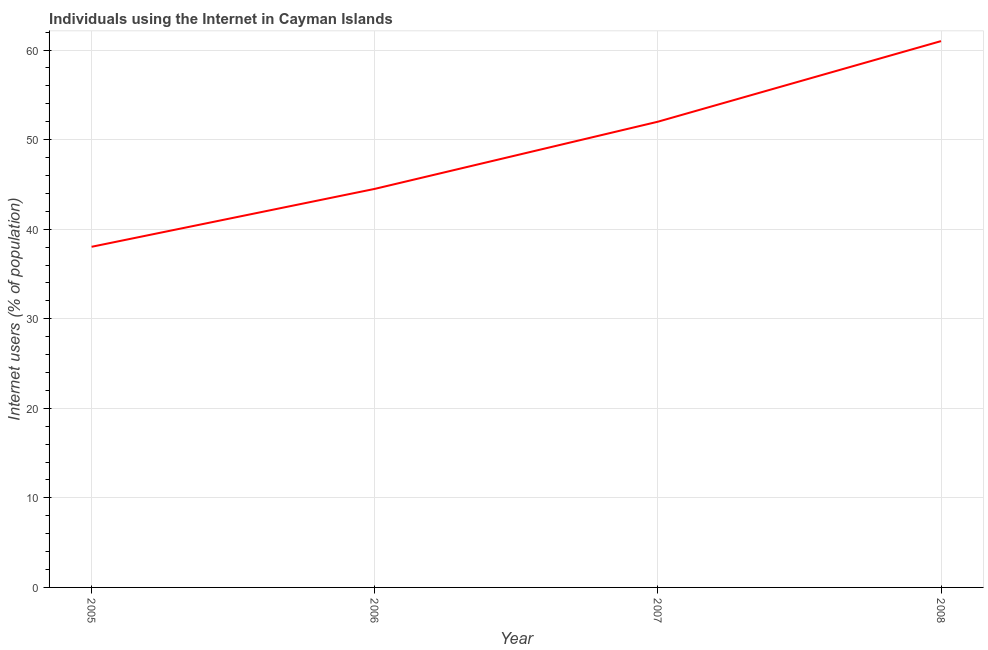What is the number of internet users in 2006?
Your response must be concise. 44.5. Across all years, what is the maximum number of internet users?
Offer a terse response. 61. Across all years, what is the minimum number of internet users?
Your answer should be very brief. 38.03. In which year was the number of internet users maximum?
Make the answer very short. 2008. What is the sum of the number of internet users?
Your answer should be compact. 195.53. What is the difference between the number of internet users in 2006 and 2008?
Offer a very short reply. -16.5. What is the average number of internet users per year?
Your answer should be compact. 48.88. What is the median number of internet users?
Provide a short and direct response. 48.25. What is the ratio of the number of internet users in 2006 to that in 2007?
Make the answer very short. 0.86. Is the number of internet users in 2006 less than that in 2008?
Your response must be concise. Yes. Is the sum of the number of internet users in 2006 and 2007 greater than the maximum number of internet users across all years?
Your response must be concise. Yes. What is the difference between the highest and the lowest number of internet users?
Ensure brevity in your answer.  22.97. Does the number of internet users monotonically increase over the years?
Provide a short and direct response. Yes. How many lines are there?
Make the answer very short. 1. How many years are there in the graph?
Your answer should be very brief. 4. What is the difference between two consecutive major ticks on the Y-axis?
Your answer should be compact. 10. Does the graph contain grids?
Your response must be concise. Yes. What is the title of the graph?
Keep it short and to the point. Individuals using the Internet in Cayman Islands. What is the label or title of the X-axis?
Keep it short and to the point. Year. What is the label or title of the Y-axis?
Give a very brief answer. Internet users (% of population). What is the Internet users (% of population) in 2005?
Provide a succinct answer. 38.03. What is the Internet users (% of population) in 2006?
Keep it short and to the point. 44.5. What is the Internet users (% of population) of 2007?
Ensure brevity in your answer.  52. What is the Internet users (% of population) of 2008?
Your answer should be compact. 61. What is the difference between the Internet users (% of population) in 2005 and 2006?
Provide a short and direct response. -6.47. What is the difference between the Internet users (% of population) in 2005 and 2007?
Offer a very short reply. -13.97. What is the difference between the Internet users (% of population) in 2005 and 2008?
Offer a very short reply. -22.97. What is the difference between the Internet users (% of population) in 2006 and 2008?
Give a very brief answer. -16.5. What is the ratio of the Internet users (% of population) in 2005 to that in 2006?
Keep it short and to the point. 0.85. What is the ratio of the Internet users (% of population) in 2005 to that in 2007?
Ensure brevity in your answer.  0.73. What is the ratio of the Internet users (% of population) in 2005 to that in 2008?
Offer a very short reply. 0.62. What is the ratio of the Internet users (% of population) in 2006 to that in 2007?
Provide a succinct answer. 0.86. What is the ratio of the Internet users (% of population) in 2006 to that in 2008?
Offer a very short reply. 0.73. What is the ratio of the Internet users (% of population) in 2007 to that in 2008?
Make the answer very short. 0.85. 